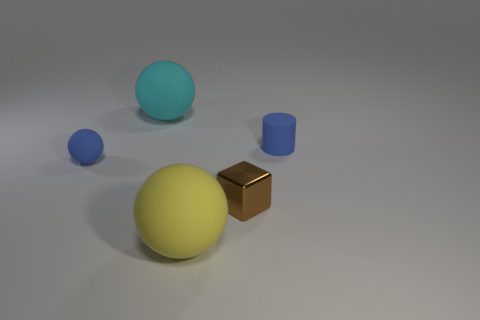Subtract all green blocks. Subtract all red spheres. How many blocks are left? 1 Add 2 cylinders. How many objects exist? 7 Subtract all blocks. How many objects are left? 4 Add 2 tiny brown things. How many tiny brown things are left? 3 Add 5 big cyan matte objects. How many big cyan matte objects exist? 6 Subtract 1 brown cubes. How many objects are left? 4 Subtract all small cubes. Subtract all rubber cylinders. How many objects are left? 3 